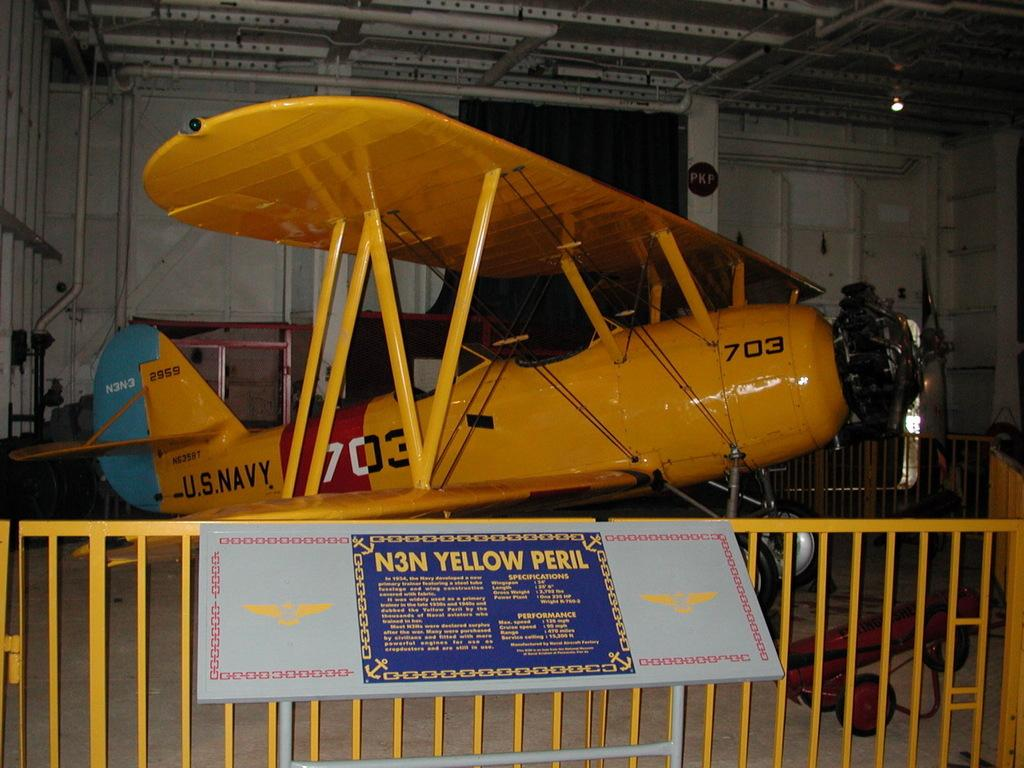Provide a one-sentence caption for the provided image. N3N yellow peril out on display that is from the U.S Navy. 